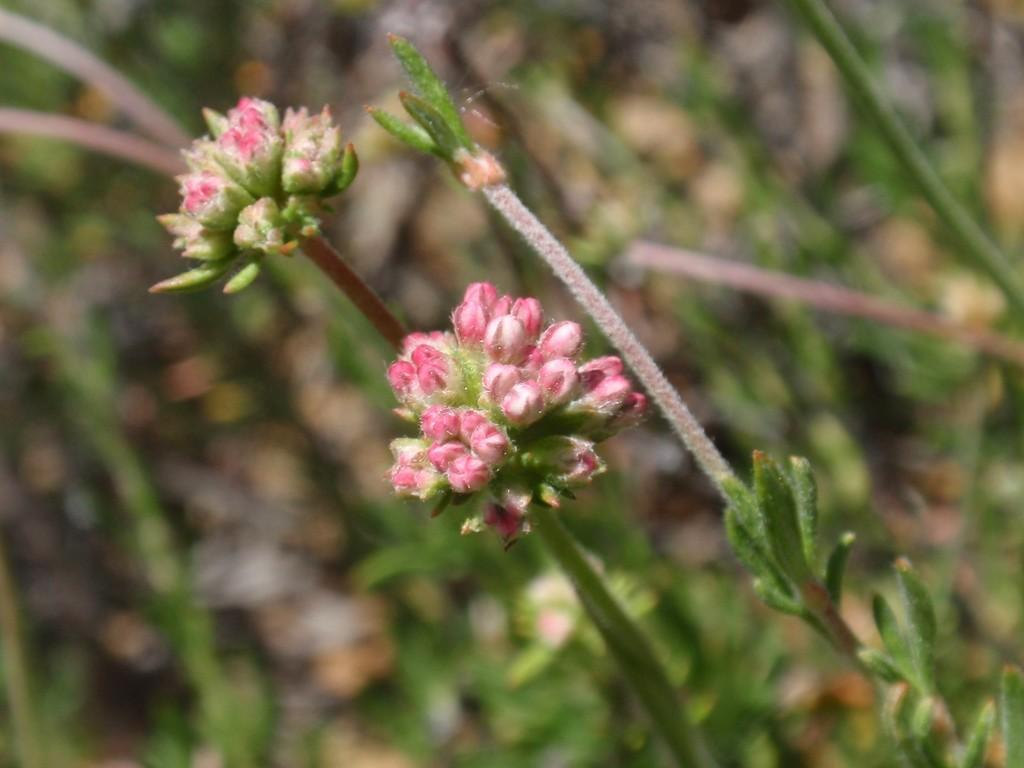What type of living organisms can be seen in the image? There are flowers in the image. What is the source of the flowers in the image? The flowers belong to a plant. How would you describe the background of the image? The background of the image is blurred. What type of reward is being given to the field in the image? There is no reward being given to a field in the image, as the image only contains flowers and a blurred background. 